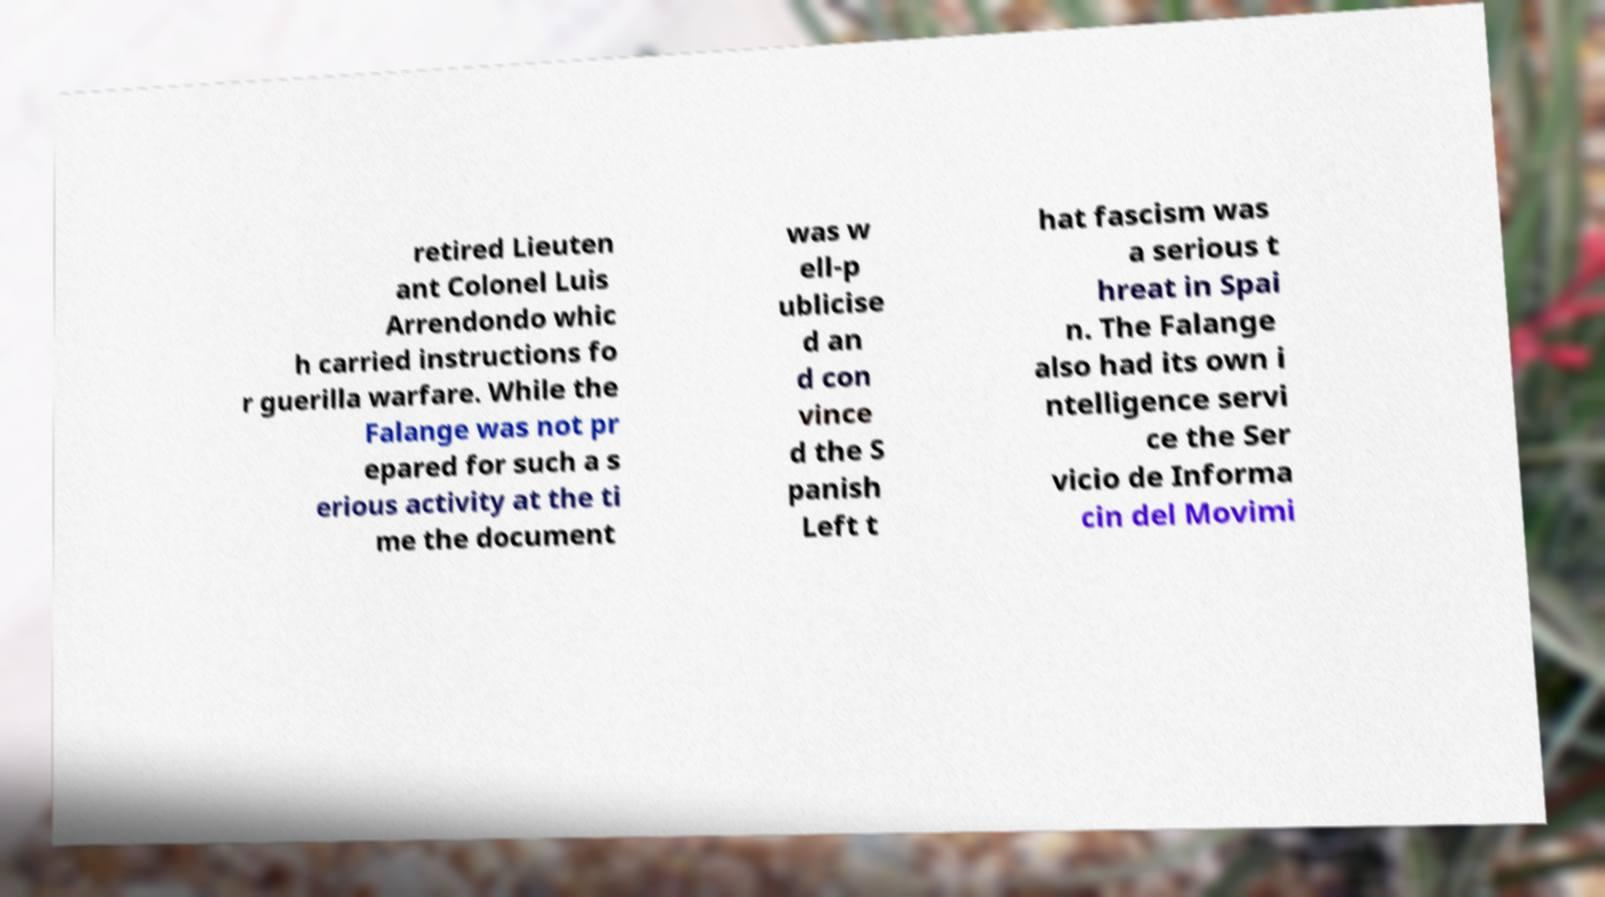For documentation purposes, I need the text within this image transcribed. Could you provide that? retired Lieuten ant Colonel Luis Arrendondo whic h carried instructions fo r guerilla warfare. While the Falange was not pr epared for such a s erious activity at the ti me the document was w ell-p ublicise d an d con vince d the S panish Left t hat fascism was a serious t hreat in Spai n. The Falange also had its own i ntelligence servi ce the Ser vicio de Informa cin del Movimi 